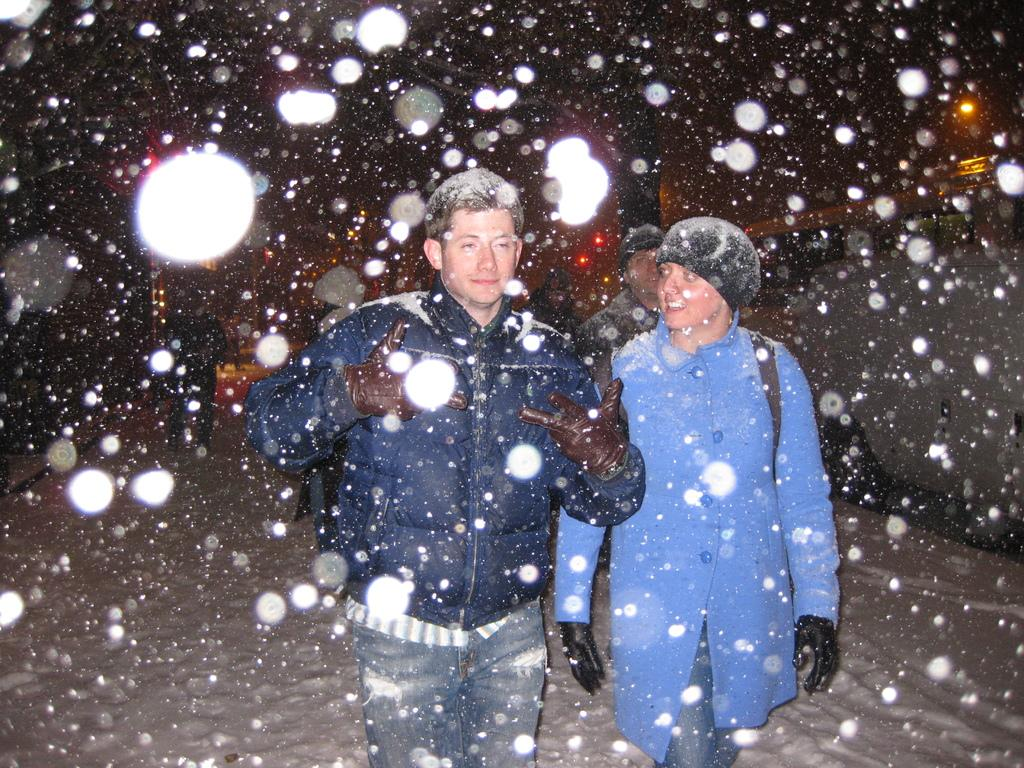Who is present in the image? There is a couple in the image. What are the couple doing in the image? The couple is walking on the snow. What is the weather like in the image? There is snowfall in the image. What is the color of the background in the image? The background of the image is dark. What is there is any mention of a specific distribution in the image? There is no mention of a specific distribution in the image. What shape is the snow taking in the image? The shape of the snow is not specified in the image, as it is depicted as snowfall. What property of the snow is being highlighted in the image? The image does not focus on a specific property of the snow; it simply shows the couple walking in the snowfall. 